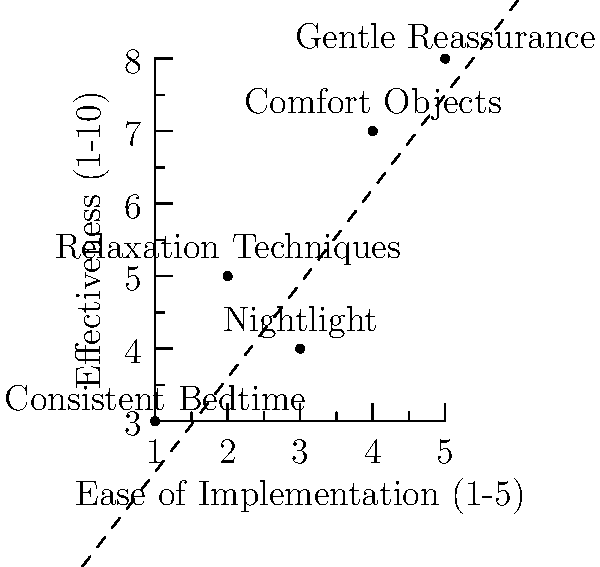Based on the scatter plot of coping techniques for night terrors, which technique appears to be the most effective while also being relatively easy to implement? Additionally, what does the dashed line represent in this context? To answer this question, we need to analyze the scatter plot:

1. The x-axis represents the ease of implementation (1-5 scale).
2. The y-axis represents the effectiveness (1-10 scale).
3. Each point represents a coping technique.

Step 1: Identify the most effective techniques
- "Gentle Reassurance" has the highest y-value (8), making it the most effective.
- "Comfort Objects" is the second most effective with a y-value of 7.

Step 2: Consider the ease of implementation
- "Gentle Reassurance" is at x=5, indicating it's also very easy to implement.
- "Comfort Objects" is at x=4, also relatively easy to implement.

Step 3: Balance effectiveness and ease of implementation
- "Gentle Reassurance" offers the best balance, being both most effective and easiest to implement.

Step 4: Interpret the dashed line
- The dashed line shows a positive correlation between ease of implementation and effectiveness.
- It suggests that techniques that are easier to implement tend to be more effective.
- This line represents the general trend of the data points.

Therefore, "Gentle Reassurance" is the most effective technique while being easy to implement, and the dashed line represents the positive correlation between ease of implementation and effectiveness of the coping techniques.
Answer: Gentle Reassurance; positive correlation between ease and effectiveness 